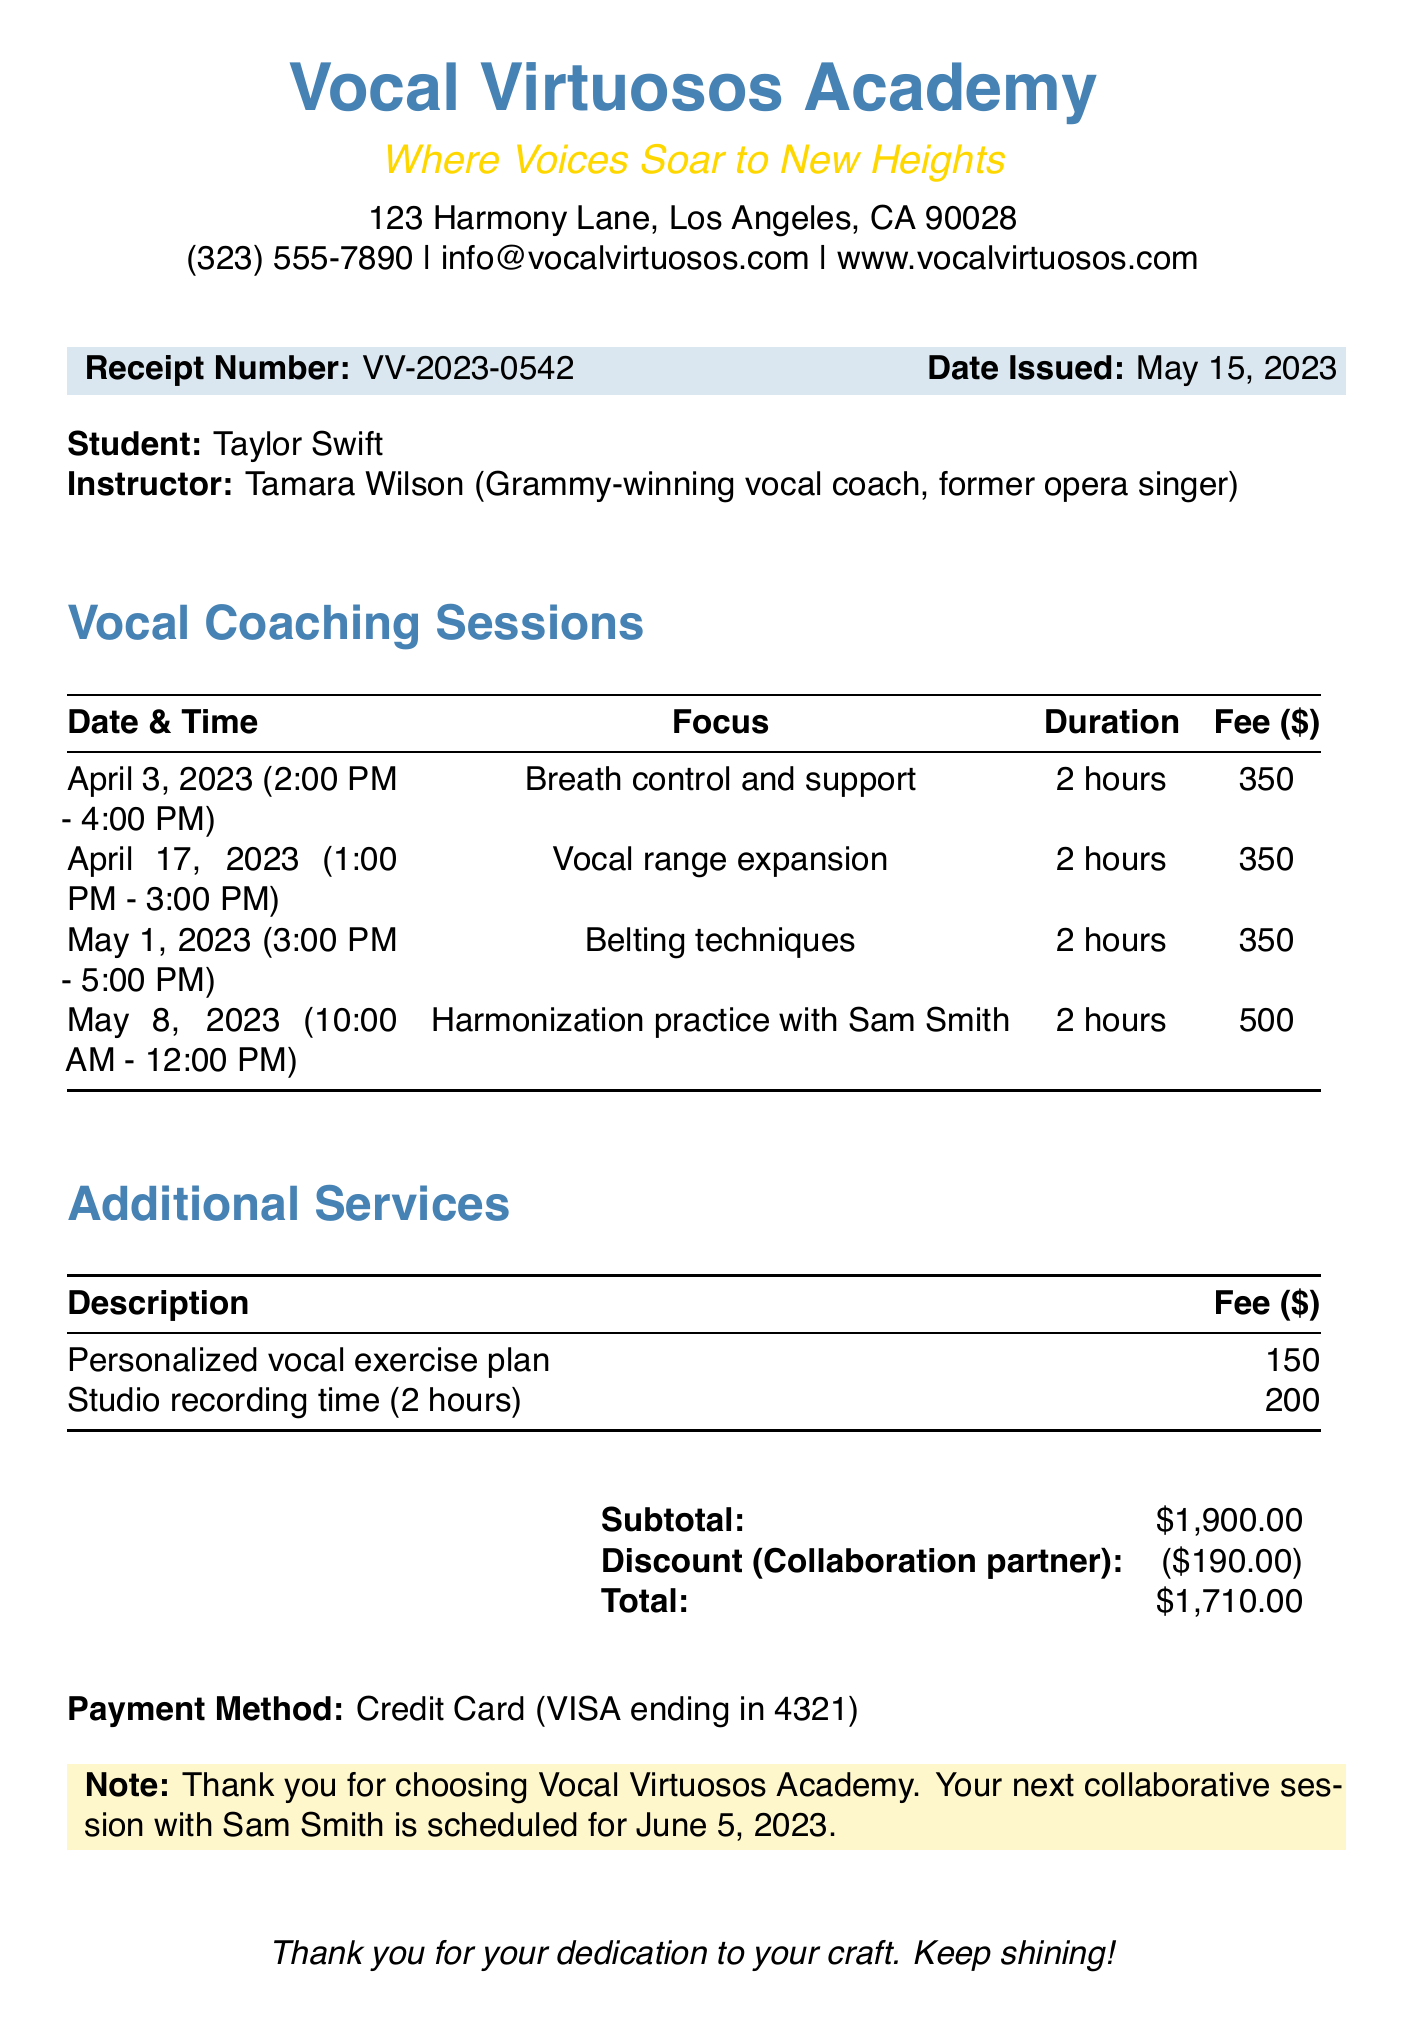What is the name of the instructor? The instructor's name is listed at the top of the document.
Answer: Tamara Wilson What is the focus of the session on April 17, 2023? This question refers to the specific focus mentioned in the lessons section for that date.
Answer: Vocal range expansion How much is the fee for the session on May 8, 2023? The fee for that specific session is mentioned directly in the lessons section of the document.
Answer: 500 What is the total amount after the discount? The total reflects the final amount due after applying the discount to the subtotal.
Answer: 1710 How many hours is each vocal coaching session? The duration of each session is consistently specified in the lessons.
Answer: 2 hours What is the subtotal amount before discounts? The subtotal amount is the sum of all the fees listed before any discounts are applied.
Answer: 1900 What additional service costs $150? This question points to the specific additional service fee described in the document.
Answer: Personalized vocal exercise plan Who is the student receiving coaching? The name of the student is provided in the introductory section of the document.
Answer: Taylor Swift What payment method was used? The payment method is stated towards the end of the document.
Answer: Credit Card (VISA ending in 4321) 